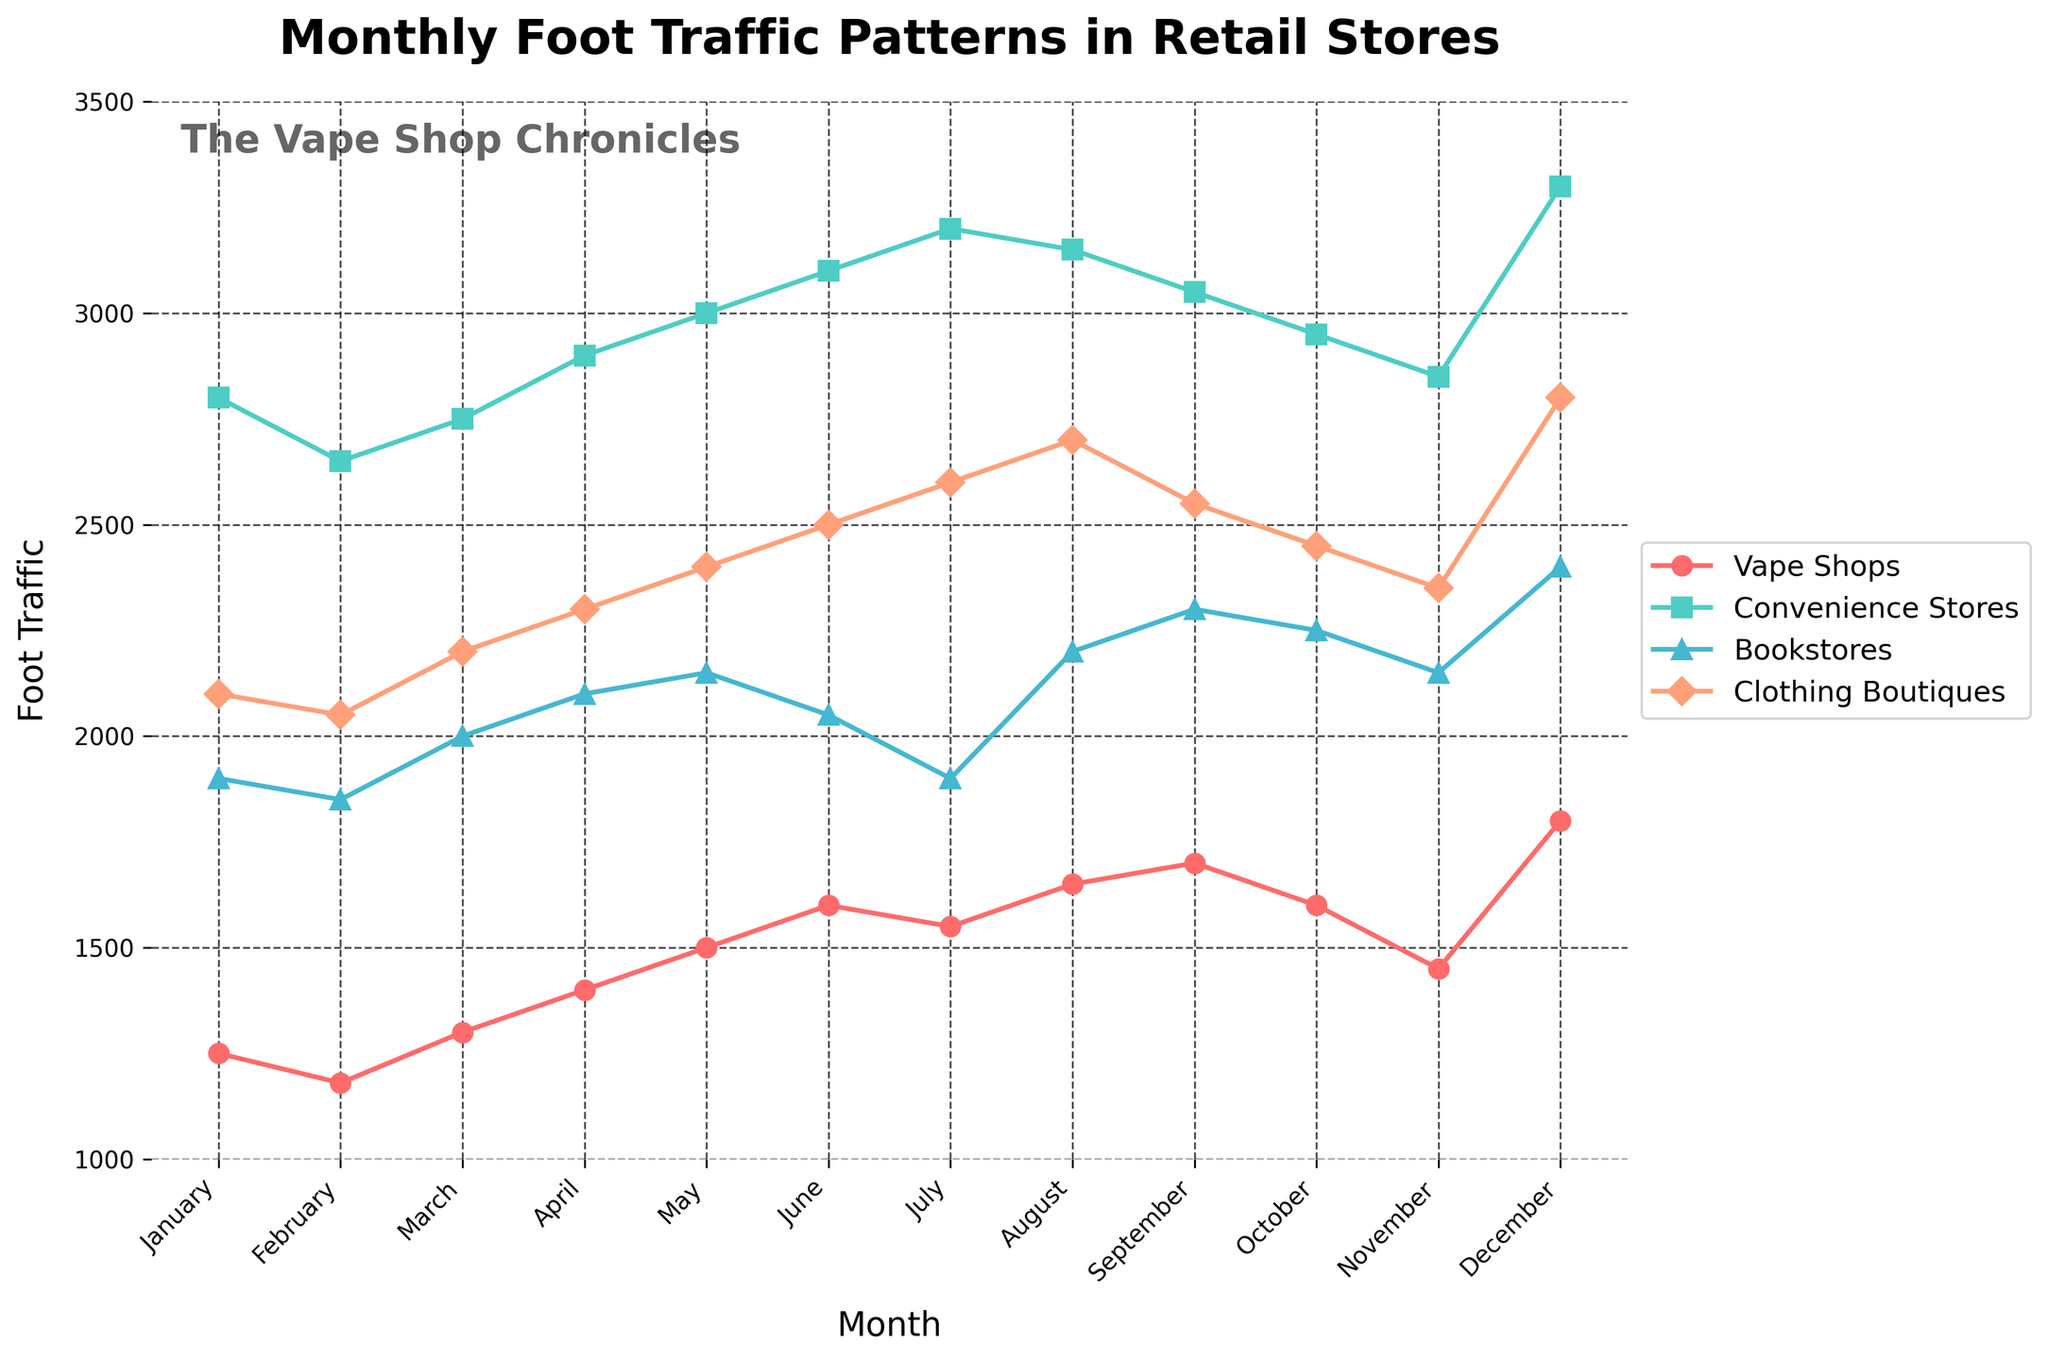Which store had the highest foot traffic in December? The figure shows the foot traffic of each store type plotted by month. You can see that 'Convenience Stores' had the highest value in December based on the line heights and endpoint values.
Answer: Convenience Stores Did vape shops have more foot traffic in July compared to April? Looking at the points and markers for 'Vape Shops' in both July and April on the chart, we can see that the foot traffic in July (1550) was less than in April (1400).
Answer: No Which store experienced an increase in foot traffic from January to December? By analyzing the lines from January to December for each store type, you can see that 'Vape Shops,' 'Convenience Stores,' 'Bookstores,' and 'Clothing Boutiques' all had increasing trends in their foot traffic.
Answer: All of them What was the difference in foot traffic between August and September for bookstores? Locate the points for 'Bookstores' in August and September: August (2200) and September (2300). The difference is calculated as 2300 - 2200 = 100.
Answer: 100 Which months saw a peak in foot traffic for clothing boutiques? By examining the peaks of the 'Clothing Boutiques' line, December stands out as the highest peak.
Answer: December Which store had the steepest increase in foot traffic from May to June? Reference the slope or steepness of the lines between May and June. The line for 'Clothing Boutiques' shows a steep increase from May (2400) to June (2500). Although in absolute numbers it is identical to 'Vape Shops,' 'Convenience Stores' and 'Bookstores,' the trend looks the steepest visually due to color contrast and marker differentiation.
Answer: Clothing Boutiques What is the average foot traffic for vape shops across the year? Identify the foot traffic for vape shops for each month: 1250, 1180, 1300, 1400, 1500, 1600, 1550, 1650, 1700, 1600, 1450, 1800. Sum these values and divide by 12: (1250 + 1180 + 1300 + 1400 + 1500 + 1600 + 1550 + 1650 + 1700 + 1600 + 1450 + 1800) / 12 = 1488.33.
Answer: 1488.33 In which month did convenience stores have the lowest foot traffic? Inspect the lowest points on the 'Convenience Stores' line throughout the year. February has the lower value (2650).
Answer: February Compare the foot traffic of bookstores to vape shops in October. Which had more? Look at the points for 'Bookstores' and 'Vape Shops' in October. Bookstores (2250) have more foot traffic compared to Vape Shops (1600).
Answer: Bookstores What is the total foot traffic for clothing boutiques over the summer months (June, July, and August)? Sum the foot traffic for 'Clothing Boutiques' for June (2500), July (2600), and August (2700): 2500 + 2600 + 2700 = 7800.
Answer: 7800 